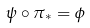Convert formula to latex. <formula><loc_0><loc_0><loc_500><loc_500>\psi \circ \pi _ { * } = \phi</formula> 